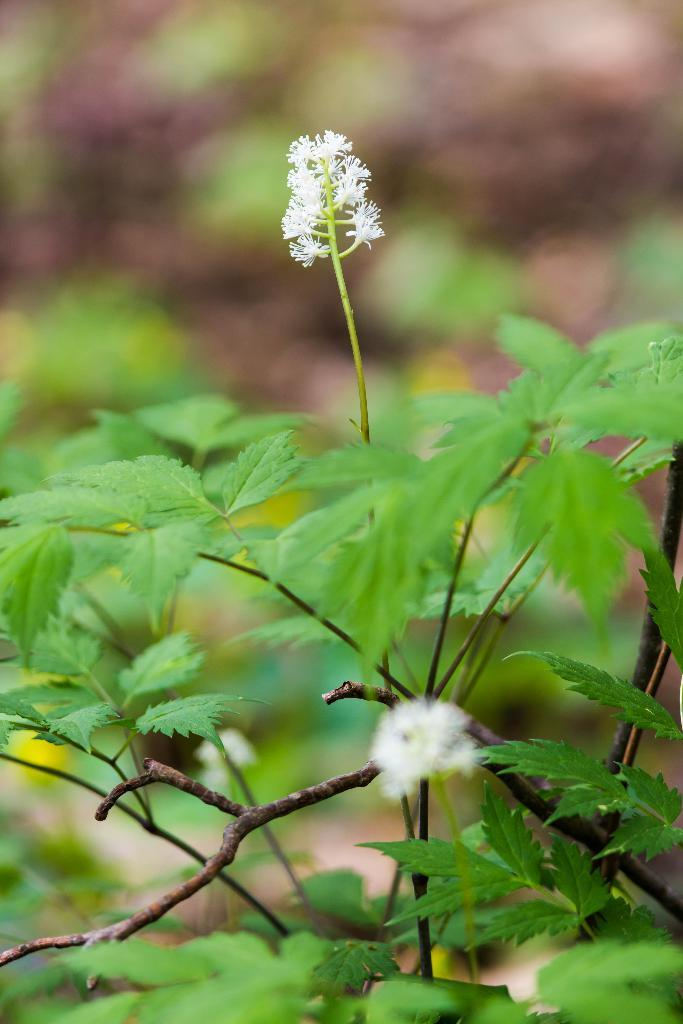What is the main subject of the image? The image contains a zoomed-in picture of a plant. What can be observed about the flowers of the plant? The plant has white flowers. How is the background of the plant presented in the image? The background of the plant is blurred. What type of kettle is visible in the image? There is no kettle present in the image; it features a zoomed-in picture of a plant with white flowers and a blurred background. 